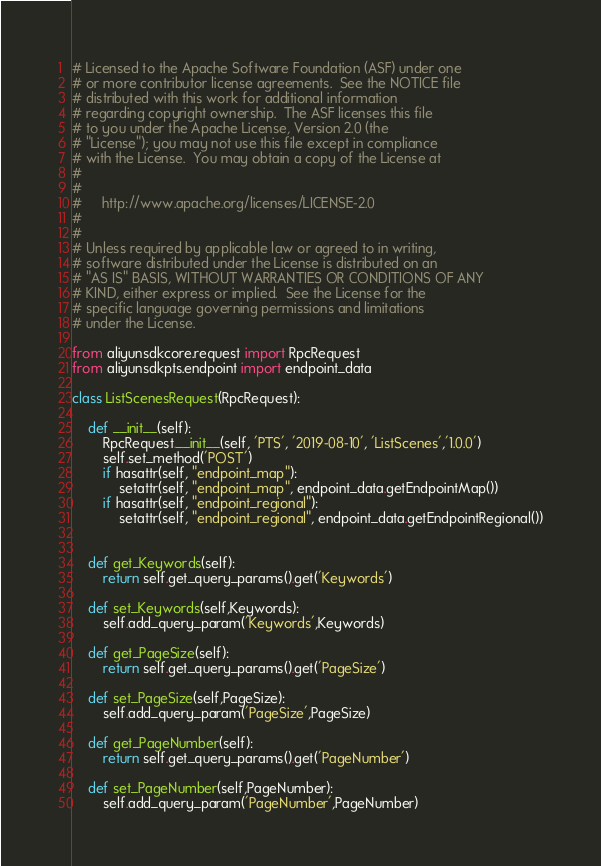<code> <loc_0><loc_0><loc_500><loc_500><_Python_># Licensed to the Apache Software Foundation (ASF) under one
# or more contributor license agreements.  See the NOTICE file
# distributed with this work for additional information
# regarding copyright ownership.  The ASF licenses this file
# to you under the Apache License, Version 2.0 (the
# "License"); you may not use this file except in compliance
# with the License.  You may obtain a copy of the License at
#
#
#     http://www.apache.org/licenses/LICENSE-2.0
#
#
# Unless required by applicable law or agreed to in writing,
# software distributed under the License is distributed on an
# "AS IS" BASIS, WITHOUT WARRANTIES OR CONDITIONS OF ANY
# KIND, either express or implied.  See the License for the
# specific language governing permissions and limitations
# under the License.

from aliyunsdkcore.request import RpcRequest
from aliyunsdkpts.endpoint import endpoint_data

class ListScenesRequest(RpcRequest):

	def __init__(self):
		RpcRequest.__init__(self, 'PTS', '2019-08-10', 'ListScenes','1.0.0')
		self.set_method('POST')
		if hasattr(self, "endpoint_map"):
			setattr(self, "endpoint_map", endpoint_data.getEndpointMap())
		if hasattr(self, "endpoint_regional"):
			setattr(self, "endpoint_regional", endpoint_data.getEndpointRegional())


	def get_Keywords(self):
		return self.get_query_params().get('Keywords')

	def set_Keywords(self,Keywords):
		self.add_query_param('Keywords',Keywords)

	def get_PageSize(self):
		return self.get_query_params().get('PageSize')

	def set_PageSize(self,PageSize):
		self.add_query_param('PageSize',PageSize)

	def get_PageNumber(self):
		return self.get_query_params().get('PageNumber')

	def set_PageNumber(self,PageNumber):
		self.add_query_param('PageNumber',PageNumber)</code> 